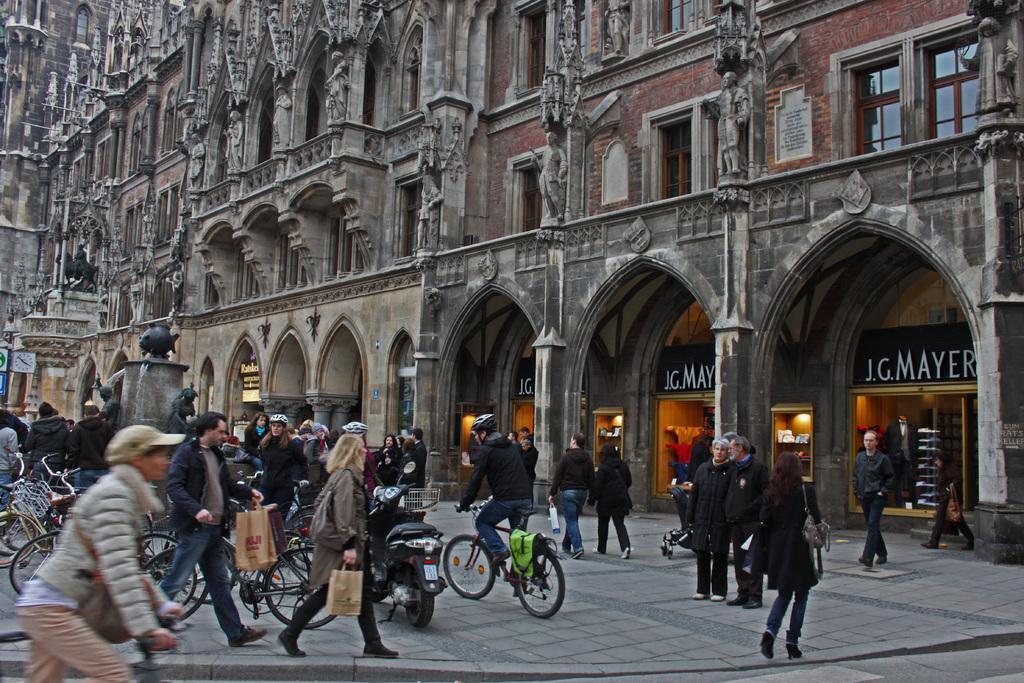How would you summarize this image in a sentence or two? In this picture there are some people walking and some of them were riding bicycles on the road. In the background there is a large building with some Windows. 